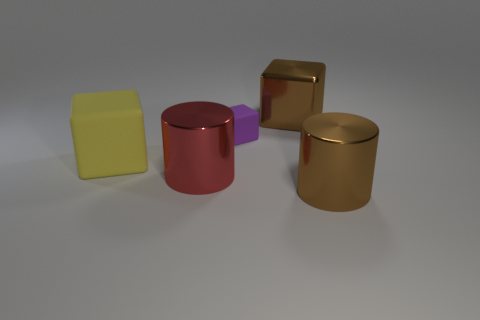Subtract all big cubes. How many cubes are left? 1 Add 1 large brown cylinders. How many objects exist? 6 Subtract 1 cubes. How many cubes are left? 2 Subtract all blue cubes. Subtract all yellow cylinders. How many cubes are left? 3 Subtract 0 yellow spheres. How many objects are left? 5 Subtract all cubes. How many objects are left? 2 Subtract all purple balls. Subtract all big yellow matte cubes. How many objects are left? 4 Add 4 metal blocks. How many metal blocks are left? 5 Add 2 big brown things. How many big brown things exist? 4 